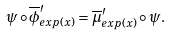Convert formula to latex. <formula><loc_0><loc_0><loc_500><loc_500>\psi \circ \overline { \phi } ^ { \prime } _ { e x p ( x ) } = \overline { \mu } ^ { \prime } _ { e x p ( x ) } \circ \psi .</formula> 